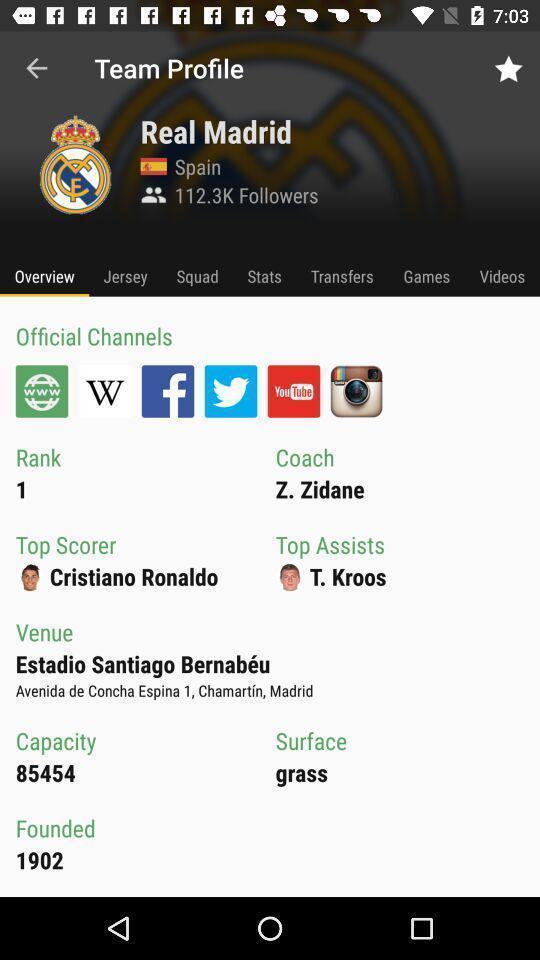Describe the content in this image. Screen displaying the team profile page. 